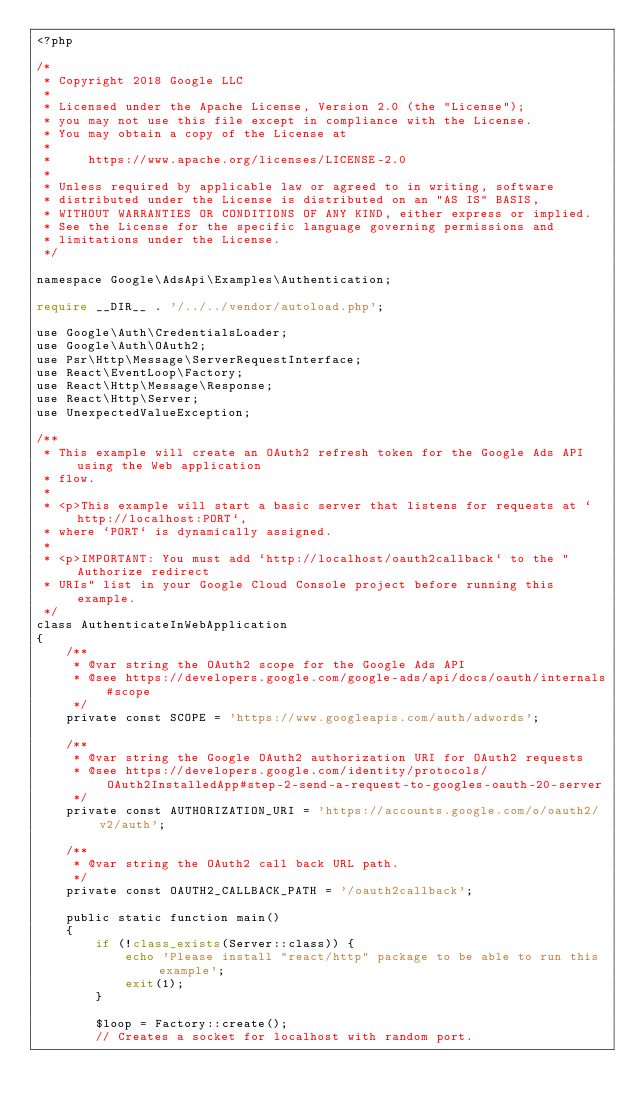<code> <loc_0><loc_0><loc_500><loc_500><_PHP_><?php

/*
 * Copyright 2018 Google LLC
 *
 * Licensed under the Apache License, Version 2.0 (the "License");
 * you may not use this file except in compliance with the License.
 * You may obtain a copy of the License at
 *
 *     https://www.apache.org/licenses/LICENSE-2.0
 *
 * Unless required by applicable law or agreed to in writing, software
 * distributed under the License is distributed on an "AS IS" BASIS,
 * WITHOUT WARRANTIES OR CONDITIONS OF ANY KIND, either express or implied.
 * See the License for the specific language governing permissions and
 * limitations under the License.
 */

namespace Google\AdsApi\Examples\Authentication;

require __DIR__ . '/../../vendor/autoload.php';

use Google\Auth\CredentialsLoader;
use Google\Auth\OAuth2;
use Psr\Http\Message\ServerRequestInterface;
use React\EventLoop\Factory;
use React\Http\Message\Response;
use React\Http\Server;
use UnexpectedValueException;

/**
 * This example will create an OAuth2 refresh token for the Google Ads API using the Web application
 * flow.
 *
 * <p>This example will start a basic server that listens for requests at `http://localhost:PORT`,
 * where `PORT` is dynamically assigned.
 *
 * <p>IMPORTANT: You must add `http://localhost/oauth2callback` to the "Authorize redirect
 * URIs" list in your Google Cloud Console project before running this example.
 */
class AuthenticateInWebApplication
{
    /**
     * @var string the OAuth2 scope for the Google Ads API
     * @see https://developers.google.com/google-ads/api/docs/oauth/internals#scope
     */
    private const SCOPE = 'https://www.googleapis.com/auth/adwords';

    /**
     * @var string the Google OAuth2 authorization URI for OAuth2 requests
     * @see https://developers.google.com/identity/protocols/OAuth2InstalledApp#step-2-send-a-request-to-googles-oauth-20-server
     */
    private const AUTHORIZATION_URI = 'https://accounts.google.com/o/oauth2/v2/auth';

    /**
     * @var string the OAuth2 call back URL path.
     */
    private const OAUTH2_CALLBACK_PATH = '/oauth2callback';

    public static function main()
    {
        if (!class_exists(Server::class)) {
            echo 'Please install "react/http" package to be able to run this example';
            exit(1);
        }

        $loop = Factory::create();
        // Creates a socket for localhost with random port.</code> 